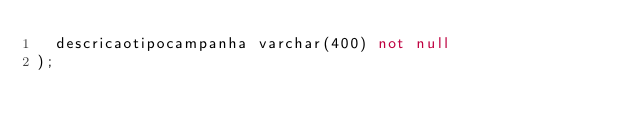<code> <loc_0><loc_0><loc_500><loc_500><_SQL_>	descricaotipocampanha varchar(400) not null
);
</code> 